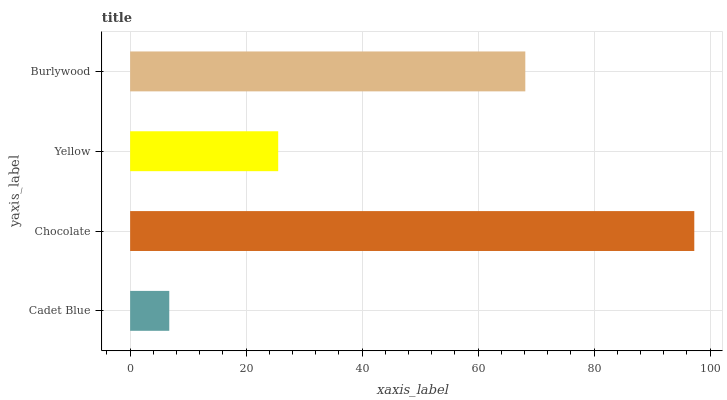Is Cadet Blue the minimum?
Answer yes or no. Yes. Is Chocolate the maximum?
Answer yes or no. Yes. Is Yellow the minimum?
Answer yes or no. No. Is Yellow the maximum?
Answer yes or no. No. Is Chocolate greater than Yellow?
Answer yes or no. Yes. Is Yellow less than Chocolate?
Answer yes or no. Yes. Is Yellow greater than Chocolate?
Answer yes or no. No. Is Chocolate less than Yellow?
Answer yes or no. No. Is Burlywood the high median?
Answer yes or no. Yes. Is Yellow the low median?
Answer yes or no. Yes. Is Yellow the high median?
Answer yes or no. No. Is Burlywood the low median?
Answer yes or no. No. 